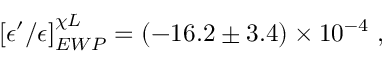Convert formula to latex. <formula><loc_0><loc_0><loc_500><loc_500>\left [ \epsilon ^ { \prime } / \epsilon \right ] _ { E W P } ^ { \chi L } = \left ( - 1 6 . 2 \pm 3 . 4 \right ) \times 1 0 ^ { - 4 } \ ,</formula> 